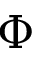Convert formula to latex. <formula><loc_0><loc_0><loc_500><loc_500>\Phi</formula> 